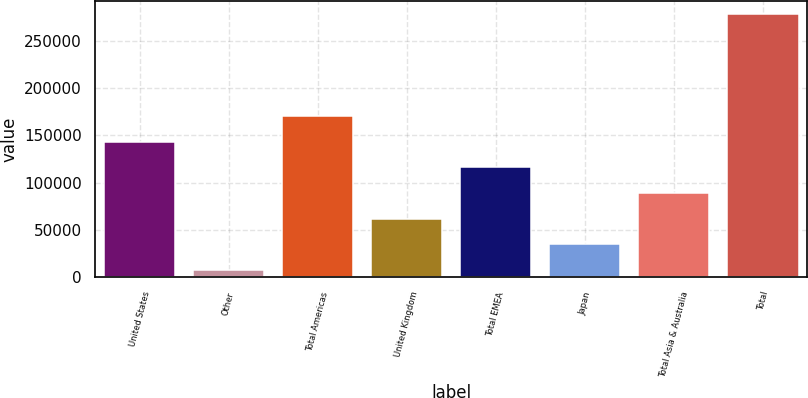Convert chart. <chart><loc_0><loc_0><loc_500><loc_500><bar_chart><fcel>United States<fcel>Other<fcel>Total Americas<fcel>United Kingdom<fcel>Total EMEA<fcel>Japan<fcel>Total Asia & Australia<fcel>Total<nl><fcel>143354<fcel>8235<fcel>170378<fcel>62282.8<fcel>116331<fcel>35258.9<fcel>89306.7<fcel>278474<nl></chart> 